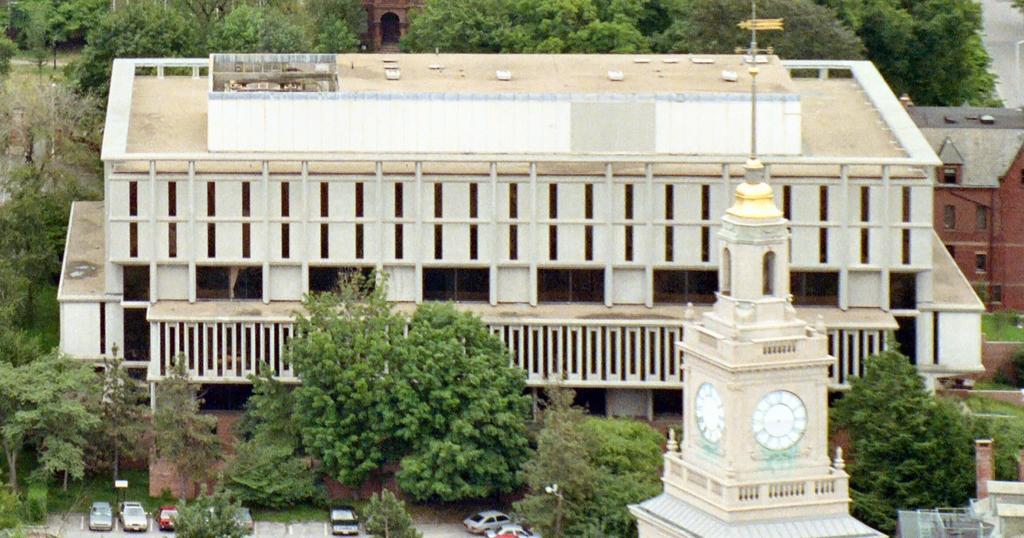Can you describe this image briefly? In this image few vehicles are on the road. Right side two clocks are attached to the wall of a tower. Background there are few trees and buildings. Right top there is a road. 